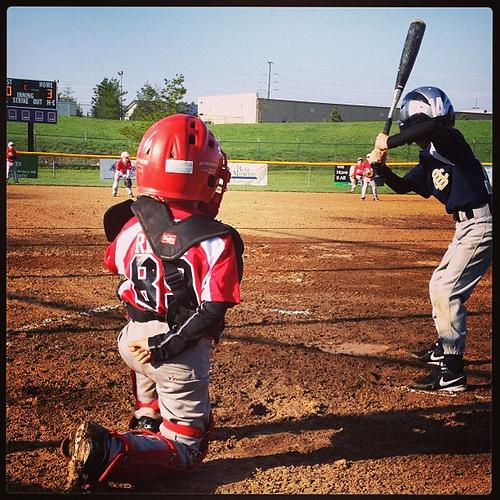Select an appropriate caption for the photograph that describes the scene. Five children playing baseball on a red earth field, with a grass-covered hill in the background and a clear sky above. List the main details seen in the baseball player's apparel and equipment. Red baseball helmet, black number on the back of the jersey, baseball bat in hands, black and white sneakers, and black and silver bat. What activity are the children engaged in, and where is this happening? The children are playing baseball in clay beneath a grass-covered hill. What color is the numeral on the jersey, and what can be seen on the top of the fence? The numeral on the jersey is black, and there is a yellow border on top of the fence. Identify the color of the helmet and the detail about the bat held by a person in the image. The helmet is red, and the person is wearing black and silver while holding a bat. What is seen in the sky of the image, and what do you notice about the earth in the playing field? The sky is mostly clear, and the playing field has red earth, grass, and red clay dirt. Describe the appearance of a player's footwear in this image. The player is wearing black and white sneakers with a white Nike logo. 